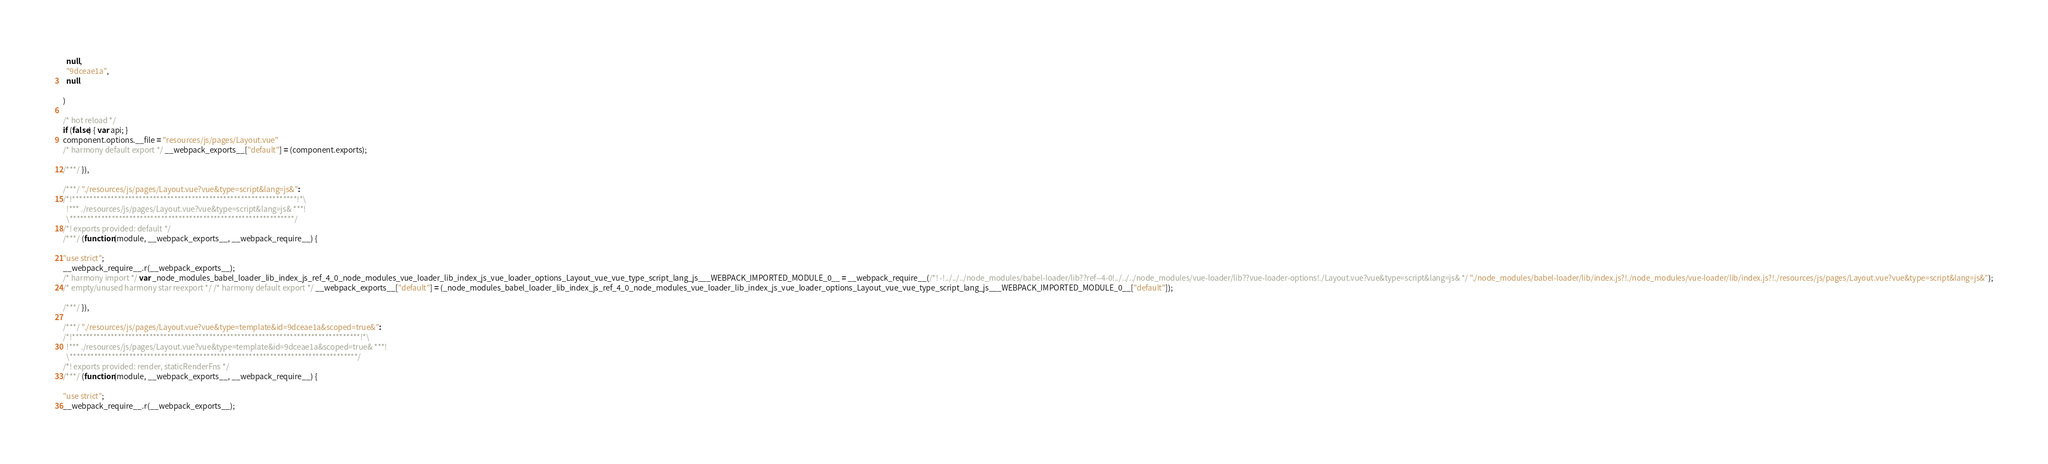Convert code to text. <code><loc_0><loc_0><loc_500><loc_500><_JavaScript_>  null,
  "9dceae1a",
  null
  
)

/* hot reload */
if (false) { var api; }
component.options.__file = "resources/js/pages/Layout.vue"
/* harmony default export */ __webpack_exports__["default"] = (component.exports);

/***/ }),

/***/ "./resources/js/pages/Layout.vue?vue&type=script&lang=js&":
/*!****************************************************************!*\
  !*** ./resources/js/pages/Layout.vue?vue&type=script&lang=js& ***!
  \****************************************************************/
/*! exports provided: default */
/***/ (function(module, __webpack_exports__, __webpack_require__) {

"use strict";
__webpack_require__.r(__webpack_exports__);
/* harmony import */ var _node_modules_babel_loader_lib_index_js_ref_4_0_node_modules_vue_loader_lib_index_js_vue_loader_options_Layout_vue_vue_type_script_lang_js___WEBPACK_IMPORTED_MODULE_0__ = __webpack_require__(/*! -!../../../node_modules/babel-loader/lib??ref--4-0!../../../node_modules/vue-loader/lib??vue-loader-options!./Layout.vue?vue&type=script&lang=js& */ "./node_modules/babel-loader/lib/index.js?!./node_modules/vue-loader/lib/index.js?!./resources/js/pages/Layout.vue?vue&type=script&lang=js&");
/* empty/unused harmony star reexport */ /* harmony default export */ __webpack_exports__["default"] = (_node_modules_babel_loader_lib_index_js_ref_4_0_node_modules_vue_loader_lib_index_js_vue_loader_options_Layout_vue_vue_type_script_lang_js___WEBPACK_IMPORTED_MODULE_0__["default"]); 

/***/ }),

/***/ "./resources/js/pages/Layout.vue?vue&type=template&id=9dceae1a&scoped=true&":
/*!**********************************************************************************!*\
  !*** ./resources/js/pages/Layout.vue?vue&type=template&id=9dceae1a&scoped=true& ***!
  \**********************************************************************************/
/*! exports provided: render, staticRenderFns */
/***/ (function(module, __webpack_exports__, __webpack_require__) {

"use strict";
__webpack_require__.r(__webpack_exports__);</code> 